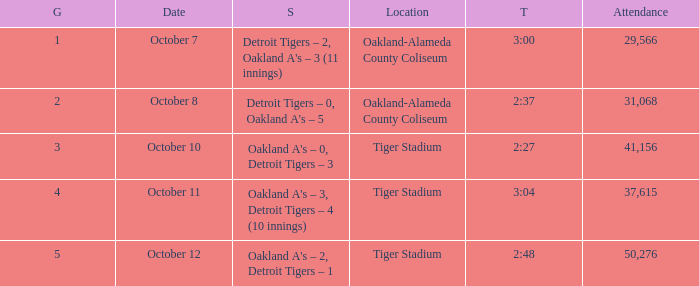What was the score at Tiger Stadium on October 12? Oakland A's – 2, Detroit Tigers – 1. 